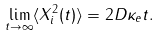<formula> <loc_0><loc_0><loc_500><loc_500>\lim _ { t \to \infty } \langle X _ { i } ^ { 2 } ( t ) \rangle = 2 D \kappa _ { e } t .</formula> 